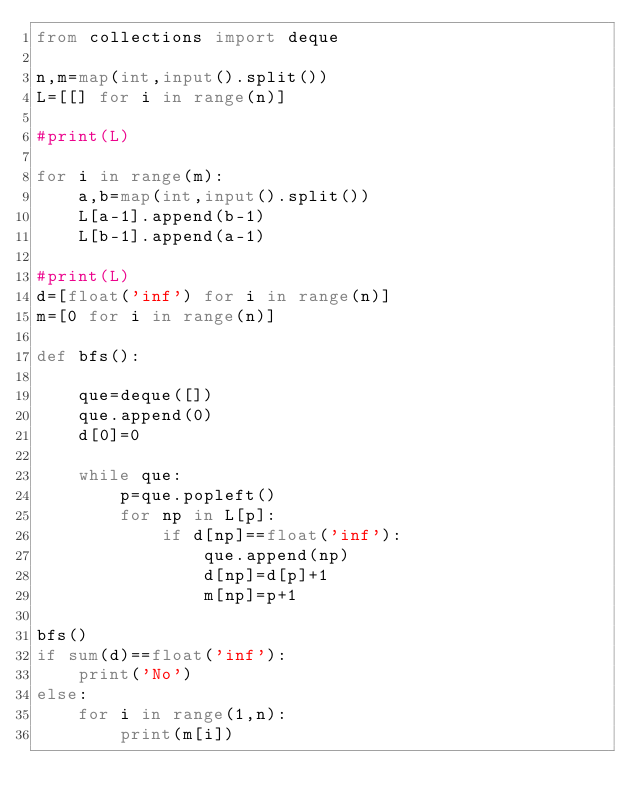<code> <loc_0><loc_0><loc_500><loc_500><_Python_>from collections import deque

n,m=map(int,input().split())
L=[[] for i in range(n)]

#print(L)

for i in range(m):
    a,b=map(int,input().split())
    L[a-1].append(b-1)
    L[b-1].append(a-1)

#print(L)
d=[float('inf') for i in range(n)]
m=[0 for i in range(n)]

def bfs():

    que=deque([])
    que.append(0)
    d[0]=0
    
    while que:
        p=que.popleft()
        for np in L[p]:
            if d[np]==float('inf'):
                que.append(np)
                d[np]=d[p]+1
                m[np]=p+1

bfs()
if sum(d)==float('inf'):
    print('No')
else:
    for i in range(1,n):
        print(m[i])</code> 